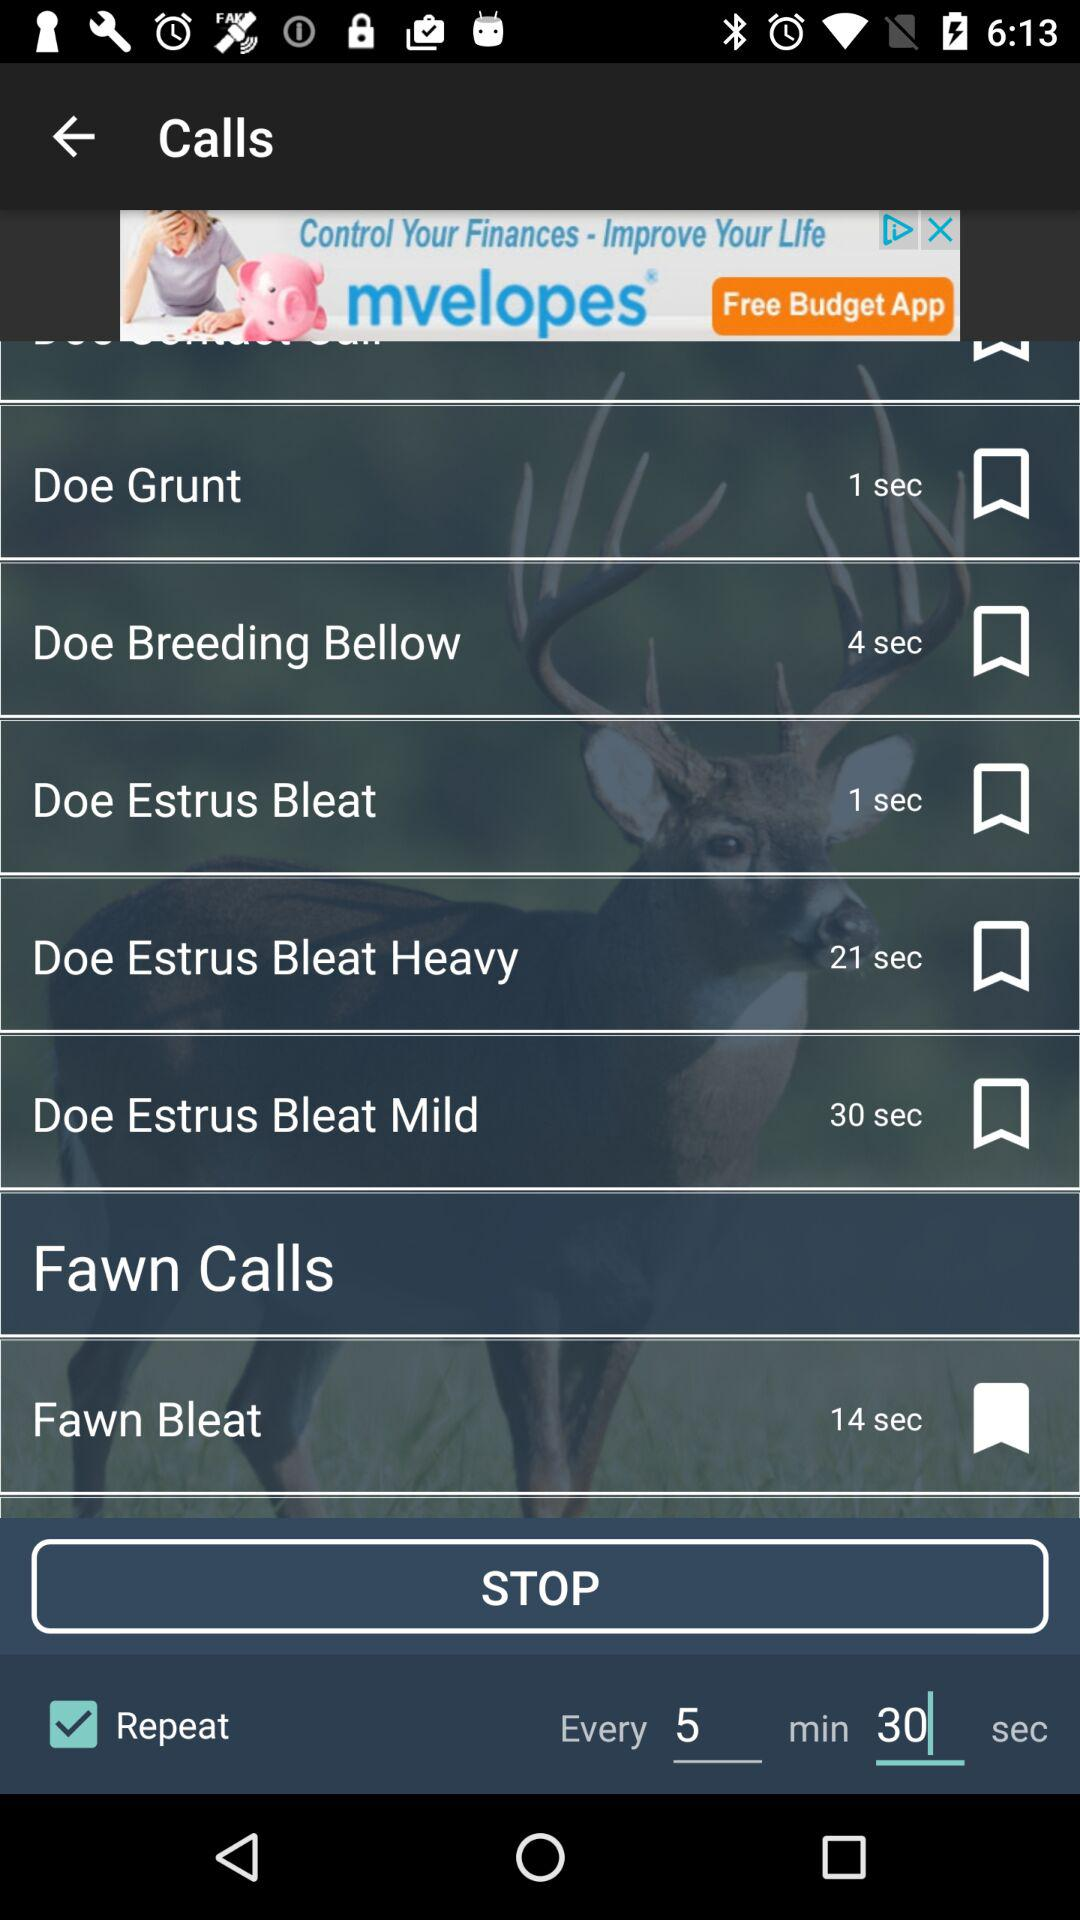How many seconds longer is the Fawn Bleat than the Doe Grunt?
Answer the question using a single word or phrase. 13 